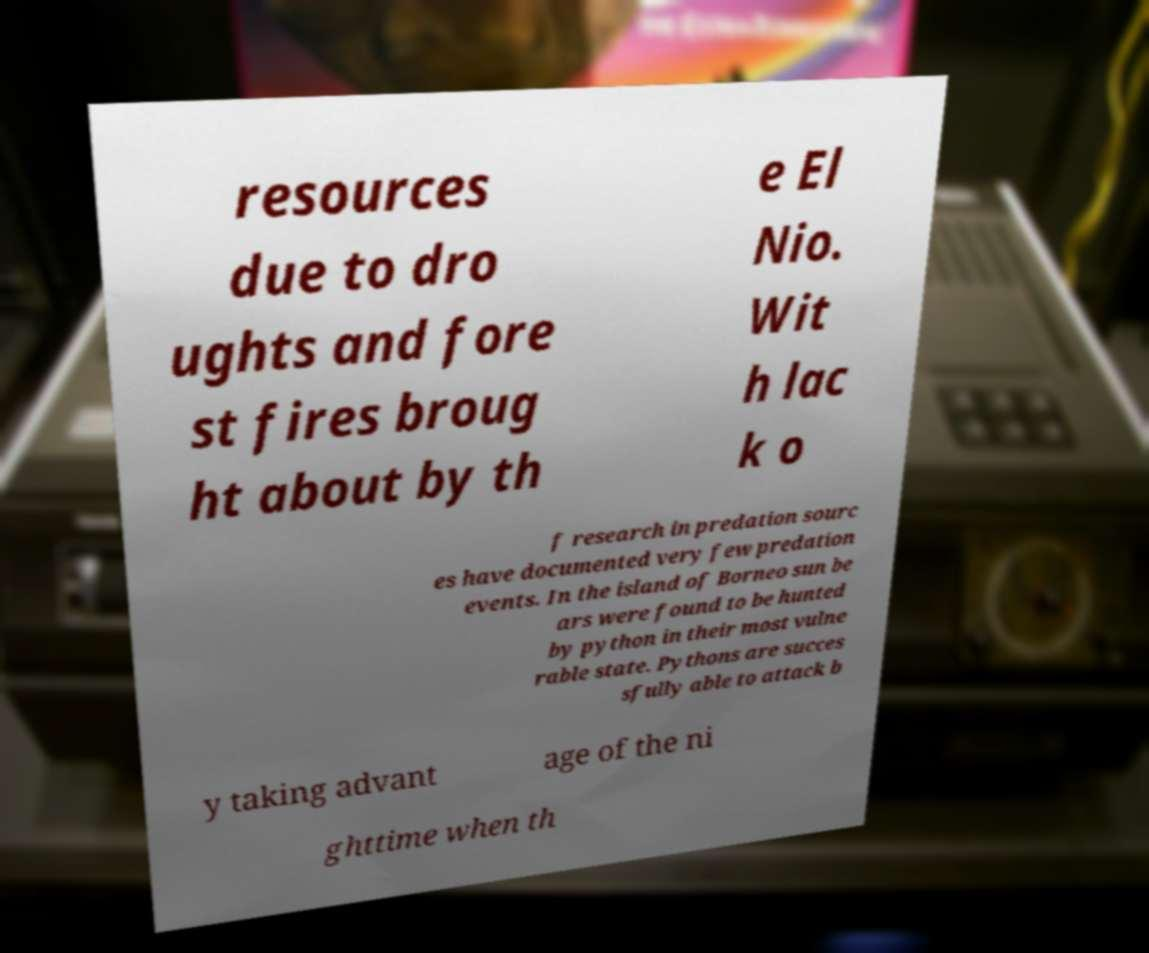Could you extract and type out the text from this image? resources due to dro ughts and fore st fires broug ht about by th e El Nio. Wit h lac k o f research in predation sourc es have documented very few predation events. In the island of Borneo sun be ars were found to be hunted by python in their most vulne rable state. Pythons are succes sfully able to attack b y taking advant age of the ni ghttime when th 